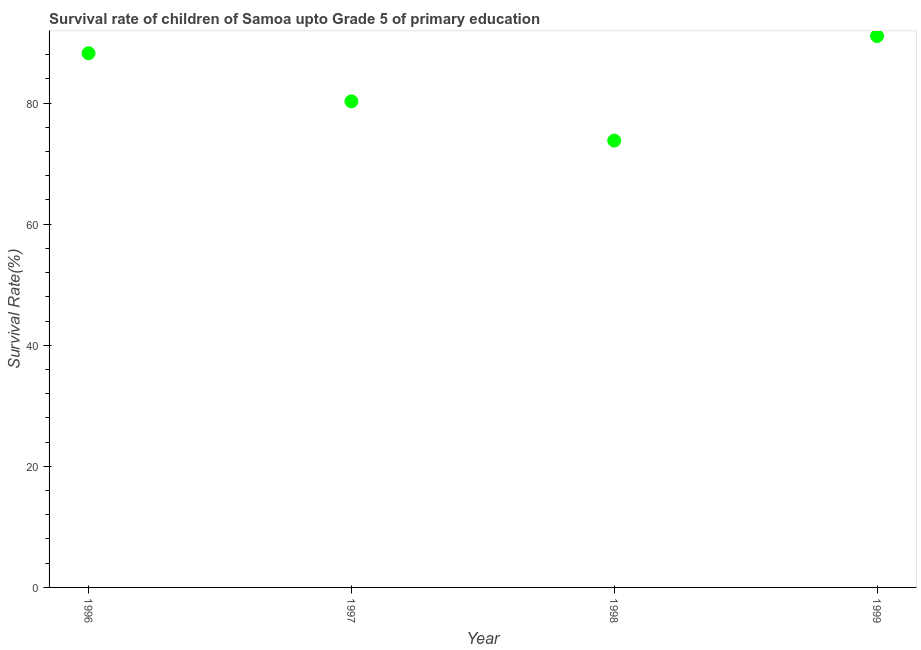What is the survival rate in 1998?
Make the answer very short. 73.8. Across all years, what is the maximum survival rate?
Your response must be concise. 91.07. Across all years, what is the minimum survival rate?
Your answer should be very brief. 73.8. What is the sum of the survival rate?
Your response must be concise. 333.38. What is the difference between the survival rate in 1996 and 1997?
Your response must be concise. 7.95. What is the average survival rate per year?
Your answer should be compact. 83.35. What is the median survival rate?
Your response must be concise. 84.26. What is the ratio of the survival rate in 1997 to that in 1999?
Provide a succinct answer. 0.88. Is the survival rate in 1996 less than that in 1997?
Offer a terse response. No. Is the difference between the survival rate in 1997 and 1998 greater than the difference between any two years?
Offer a terse response. No. What is the difference between the highest and the second highest survival rate?
Offer a terse response. 2.84. Is the sum of the survival rate in 1996 and 1997 greater than the maximum survival rate across all years?
Provide a succinct answer. Yes. What is the difference between the highest and the lowest survival rate?
Provide a succinct answer. 17.26. What is the difference between two consecutive major ticks on the Y-axis?
Make the answer very short. 20. Are the values on the major ticks of Y-axis written in scientific E-notation?
Give a very brief answer. No. Does the graph contain any zero values?
Make the answer very short. No. What is the title of the graph?
Your answer should be very brief. Survival rate of children of Samoa upto Grade 5 of primary education. What is the label or title of the X-axis?
Make the answer very short. Year. What is the label or title of the Y-axis?
Make the answer very short. Survival Rate(%). What is the Survival Rate(%) in 1996?
Your answer should be very brief. 88.23. What is the Survival Rate(%) in 1997?
Make the answer very short. 80.28. What is the Survival Rate(%) in 1998?
Your answer should be very brief. 73.8. What is the Survival Rate(%) in 1999?
Provide a short and direct response. 91.07. What is the difference between the Survival Rate(%) in 1996 and 1997?
Your answer should be compact. 7.95. What is the difference between the Survival Rate(%) in 1996 and 1998?
Your response must be concise. 14.43. What is the difference between the Survival Rate(%) in 1996 and 1999?
Offer a terse response. -2.84. What is the difference between the Survival Rate(%) in 1997 and 1998?
Offer a very short reply. 6.48. What is the difference between the Survival Rate(%) in 1997 and 1999?
Your answer should be very brief. -10.78. What is the difference between the Survival Rate(%) in 1998 and 1999?
Make the answer very short. -17.26. What is the ratio of the Survival Rate(%) in 1996 to that in 1997?
Ensure brevity in your answer.  1.1. What is the ratio of the Survival Rate(%) in 1996 to that in 1998?
Ensure brevity in your answer.  1.2. What is the ratio of the Survival Rate(%) in 1997 to that in 1998?
Provide a succinct answer. 1.09. What is the ratio of the Survival Rate(%) in 1997 to that in 1999?
Ensure brevity in your answer.  0.88. What is the ratio of the Survival Rate(%) in 1998 to that in 1999?
Give a very brief answer. 0.81. 